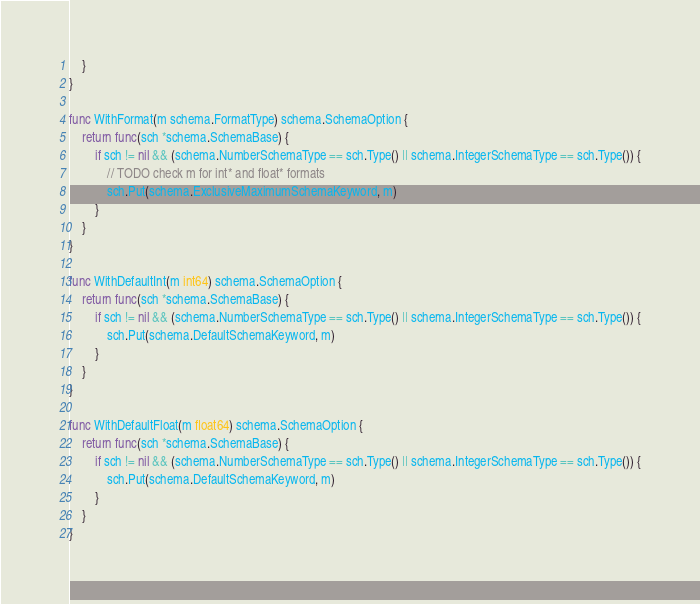<code> <loc_0><loc_0><loc_500><loc_500><_Go_>	}
}

func WithFormat(m schema.FormatType) schema.SchemaOption {
	return func(sch *schema.SchemaBase) {
		if sch != nil && (schema.NumberSchemaType == sch.Type() || schema.IntegerSchemaType == sch.Type()) {
			// TODO check m for int* and float* formats
			sch.Put(schema.ExclusiveMaximumSchemaKeyword, m)
		}
	}
}

func WithDefaultInt(m int64) schema.SchemaOption {
	return func(sch *schema.SchemaBase) {
		if sch != nil && (schema.NumberSchemaType == sch.Type() || schema.IntegerSchemaType == sch.Type()) {
			sch.Put(schema.DefaultSchemaKeyword, m)
		}
	}
}

func WithDefaultFloat(m float64) schema.SchemaOption {
	return func(sch *schema.SchemaBase) {
		if sch != nil && (schema.NumberSchemaType == sch.Type() || schema.IntegerSchemaType == sch.Type()) {
			sch.Put(schema.DefaultSchemaKeyword, m)
		}
	}
}
</code> 